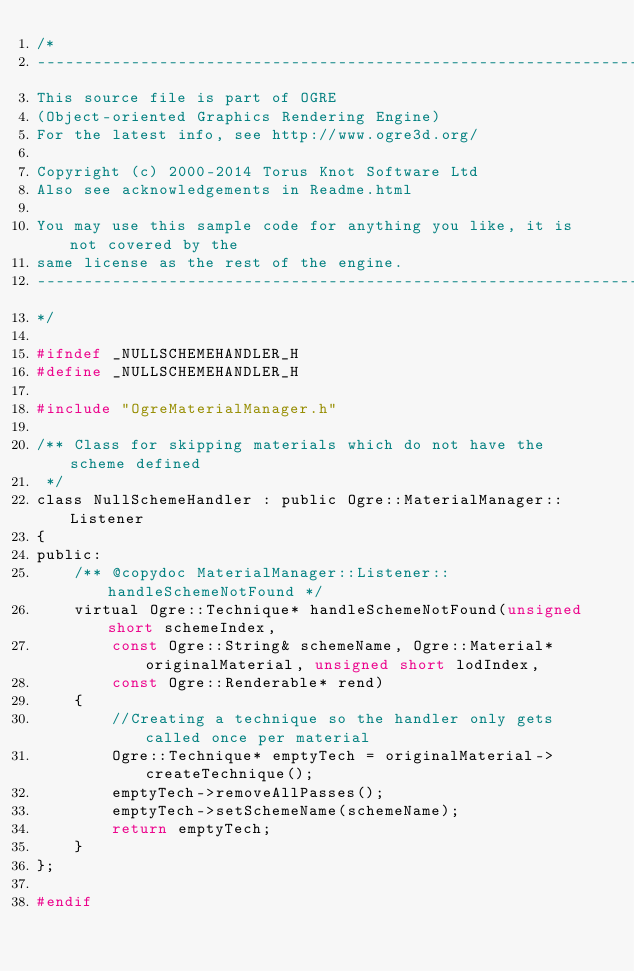<code> <loc_0><loc_0><loc_500><loc_500><_C_>/*
-----------------------------------------------------------------------------
This source file is part of OGRE
(Object-oriented Graphics Rendering Engine)
For the latest info, see http://www.ogre3d.org/

Copyright (c) 2000-2014 Torus Knot Software Ltd
Also see acknowledgements in Readme.html

You may use this sample code for anything you like, it is not covered by the
same license as the rest of the engine.
-----------------------------------------------------------------------------
*/

#ifndef _NULLSCHEMEHANDLER_H
#define _NULLSCHEMEHANDLER_H

#include "OgreMaterialManager.h"

/** Class for skipping materials which do not have the scheme defined
 */
class NullSchemeHandler : public Ogre::MaterialManager::Listener
{
public:
    /** @copydoc MaterialManager::Listener::handleSchemeNotFound */
    virtual Ogre::Technique* handleSchemeNotFound(unsigned short schemeIndex, 
        const Ogre::String& schemeName, Ogre::Material* originalMaterial, unsigned short lodIndex, 
        const Ogre::Renderable* rend)
    {
        //Creating a technique so the handler only gets called once per material
        Ogre::Technique* emptyTech = originalMaterial->createTechnique();
        emptyTech->removeAllPasses();
        emptyTech->setSchemeName(schemeName);
        return emptyTech;
    }
};

#endif
</code> 